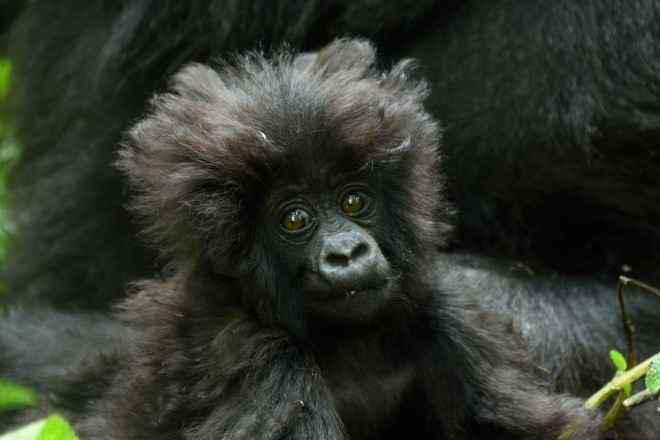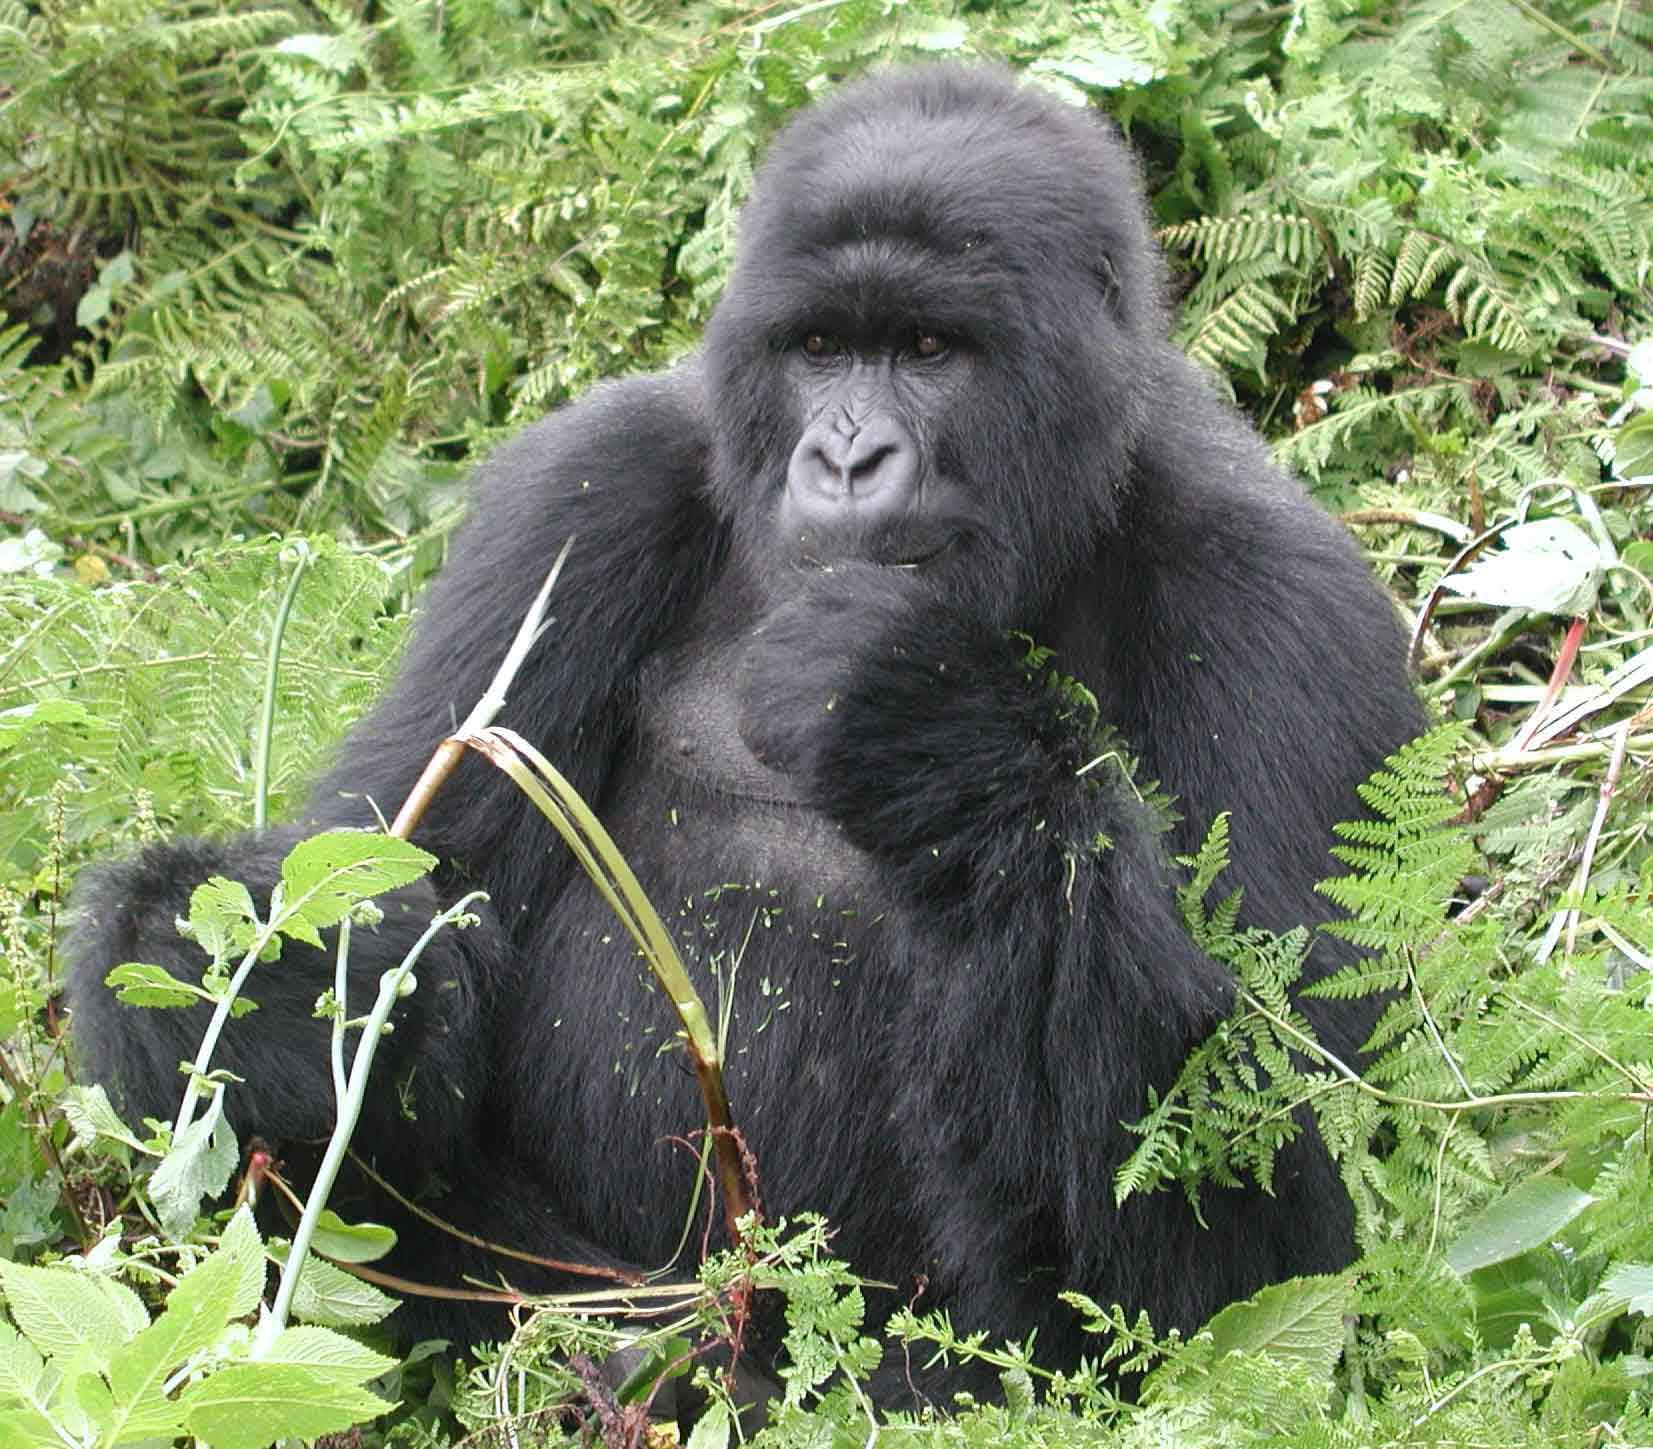The first image is the image on the left, the second image is the image on the right. Evaluate the accuracy of this statement regarding the images: "There are no more than four monkeys.". Is it true? Answer yes or no. Yes. The first image is the image on the left, the second image is the image on the right. Analyze the images presented: Is the assertion "There are no more than two baby gorillas in both images." valid? Answer yes or no. Yes. 